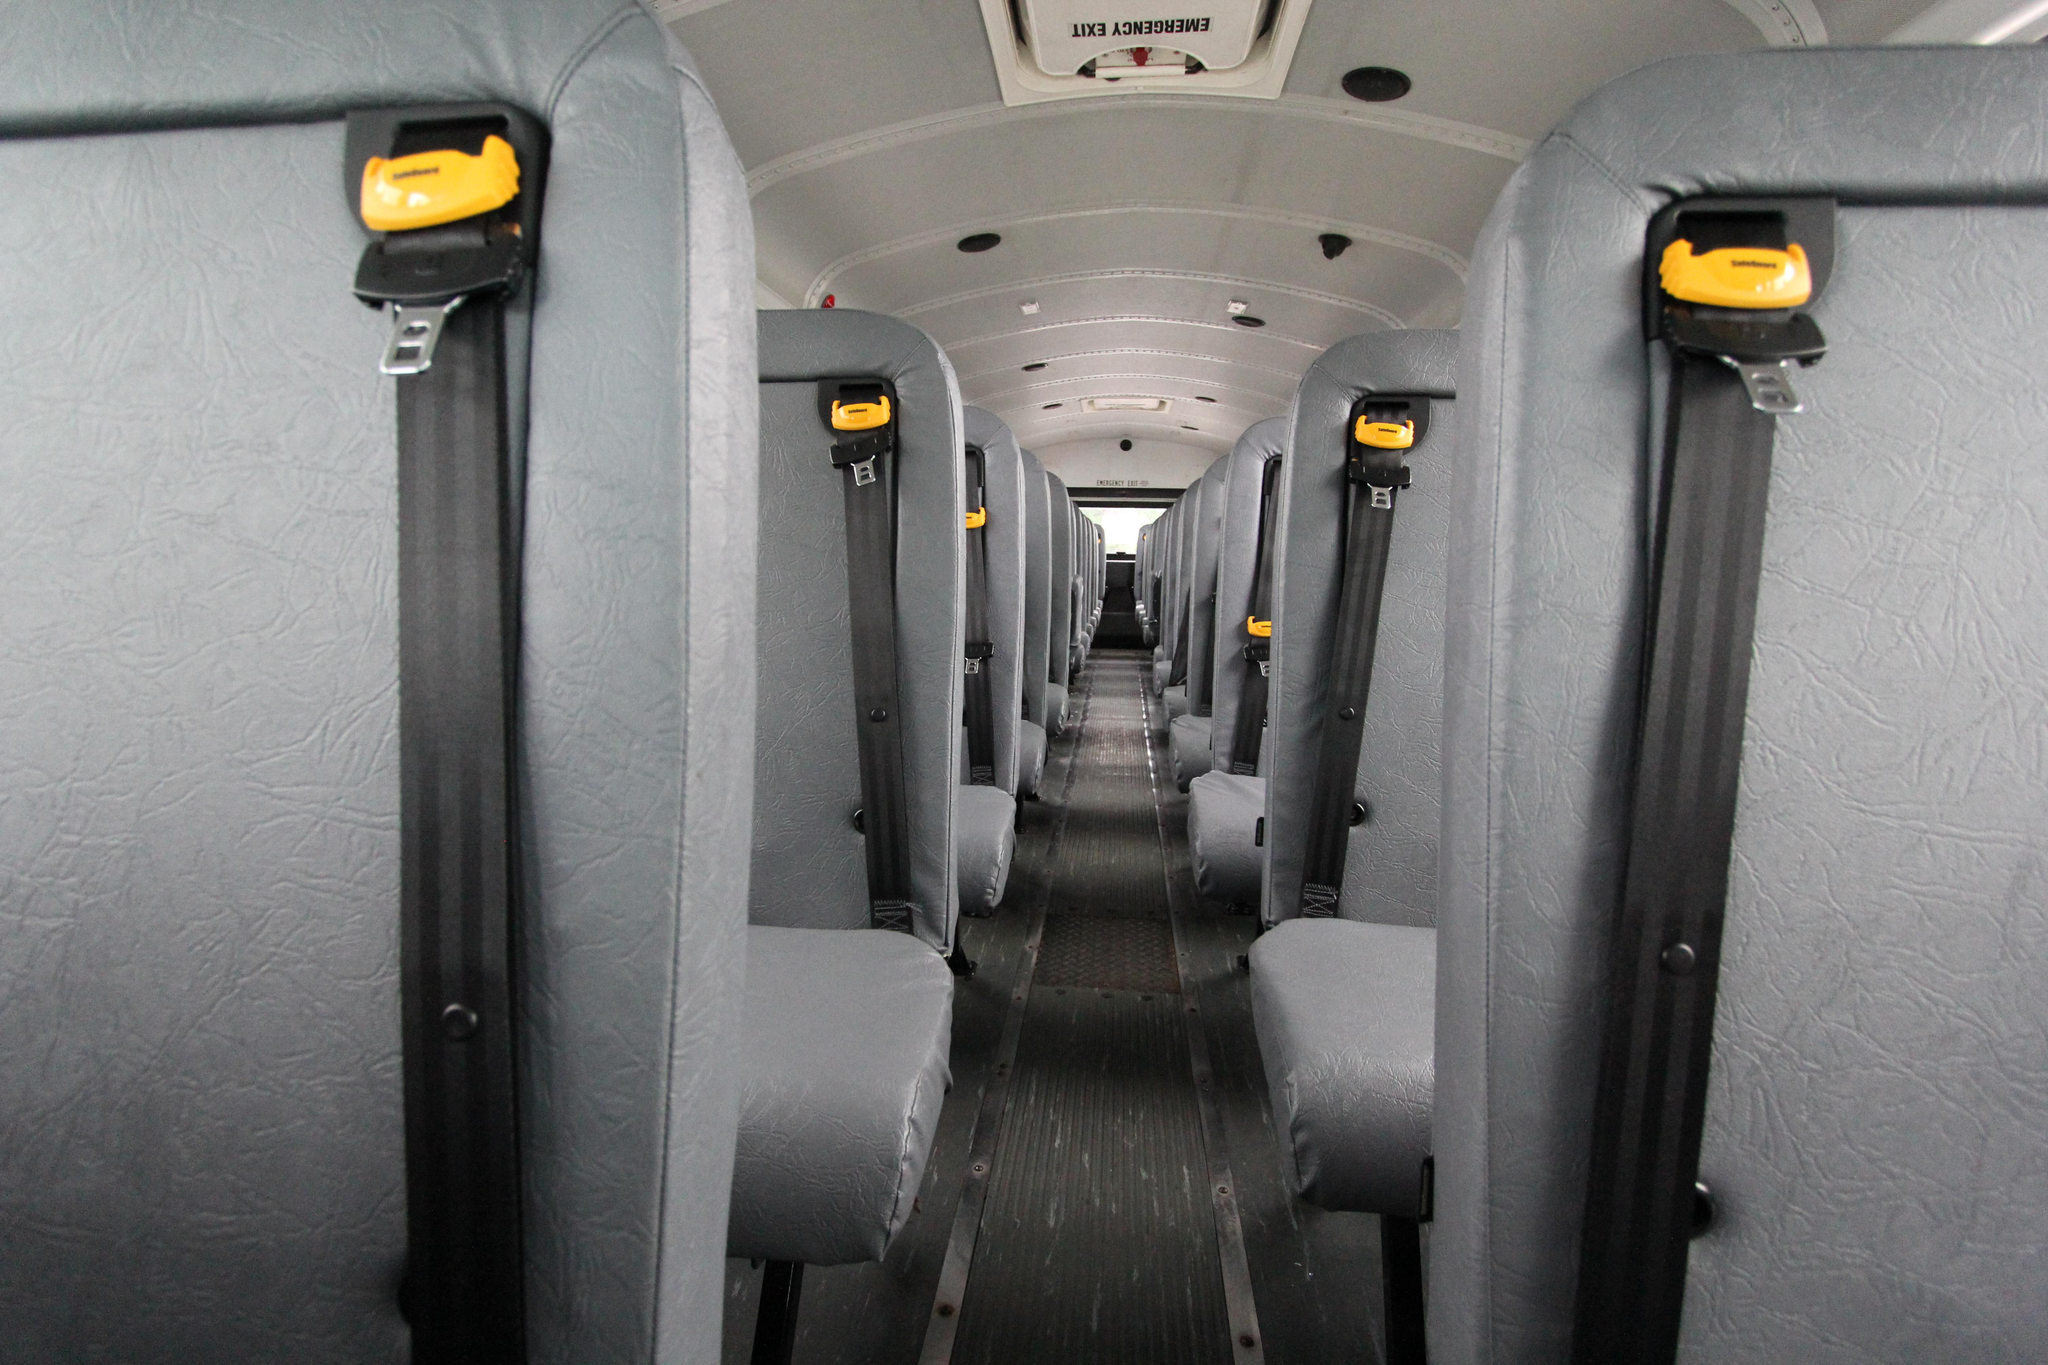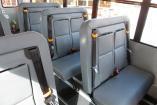The first image is the image on the left, the second image is the image on the right. Evaluate the accuracy of this statement regarding the images: "In one of the images the steering wheel is visible.". Is it true? Answer yes or no. No. The first image is the image on the left, the second image is the image on the right. For the images shown, is this caption "One image shows a head-on view of the aisle inside a bus, which has grayish seats and black seatbelts with bright yellow locking mechanisms." true? Answer yes or no. Yes. 